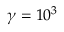<formula> <loc_0><loc_0><loc_500><loc_500>\gamma = 1 0 ^ { 3 }</formula> 